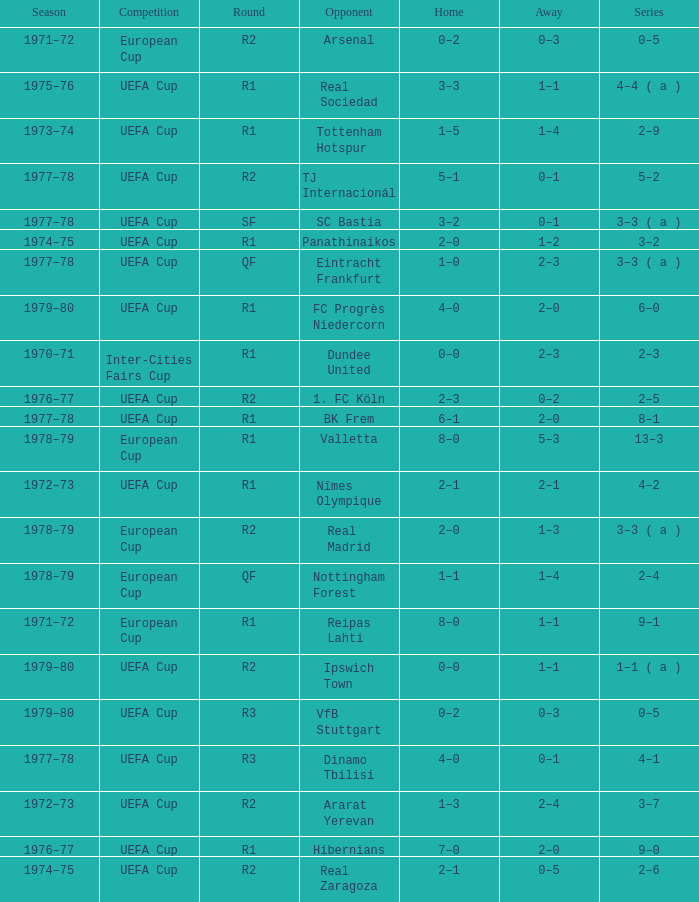Which Round has a Competition of uefa cup, and a Series of 5–2? R2. 